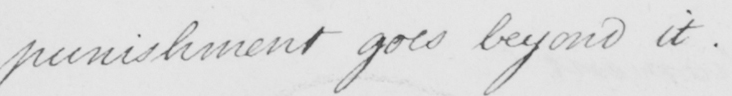Can you tell me what this handwritten text says? punishment goes beyond it .  _ 